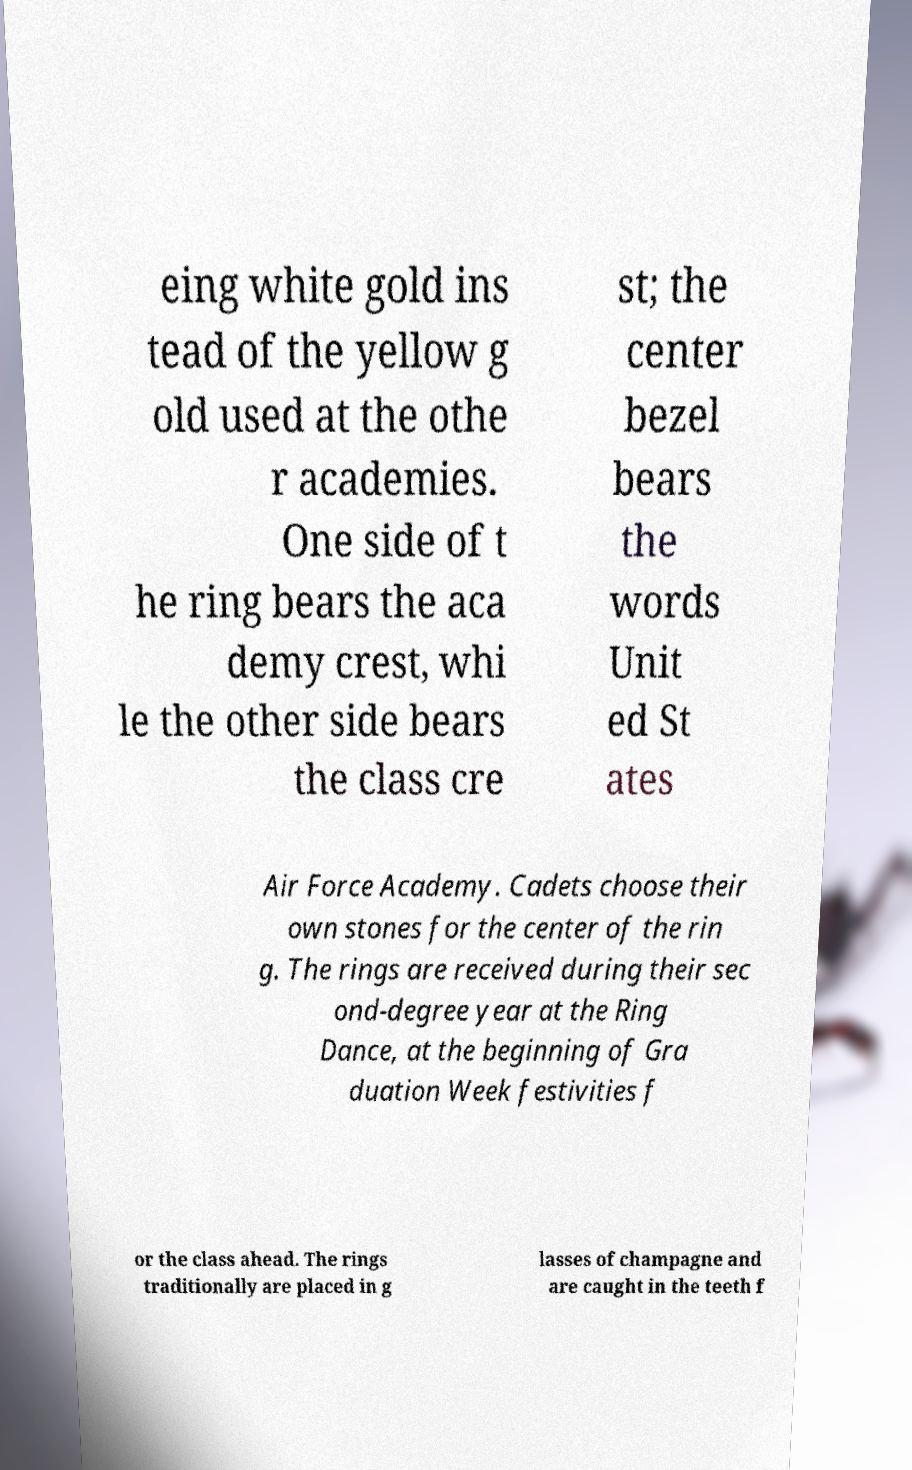For documentation purposes, I need the text within this image transcribed. Could you provide that? eing white gold ins tead of the yellow g old used at the othe r academies. One side of t he ring bears the aca demy crest, whi le the other side bears the class cre st; the center bezel bears the words Unit ed St ates Air Force Academy. Cadets choose their own stones for the center of the rin g. The rings are received during their sec ond-degree year at the Ring Dance, at the beginning of Gra duation Week festivities f or the class ahead. The rings traditionally are placed in g lasses of champagne and are caught in the teeth f 